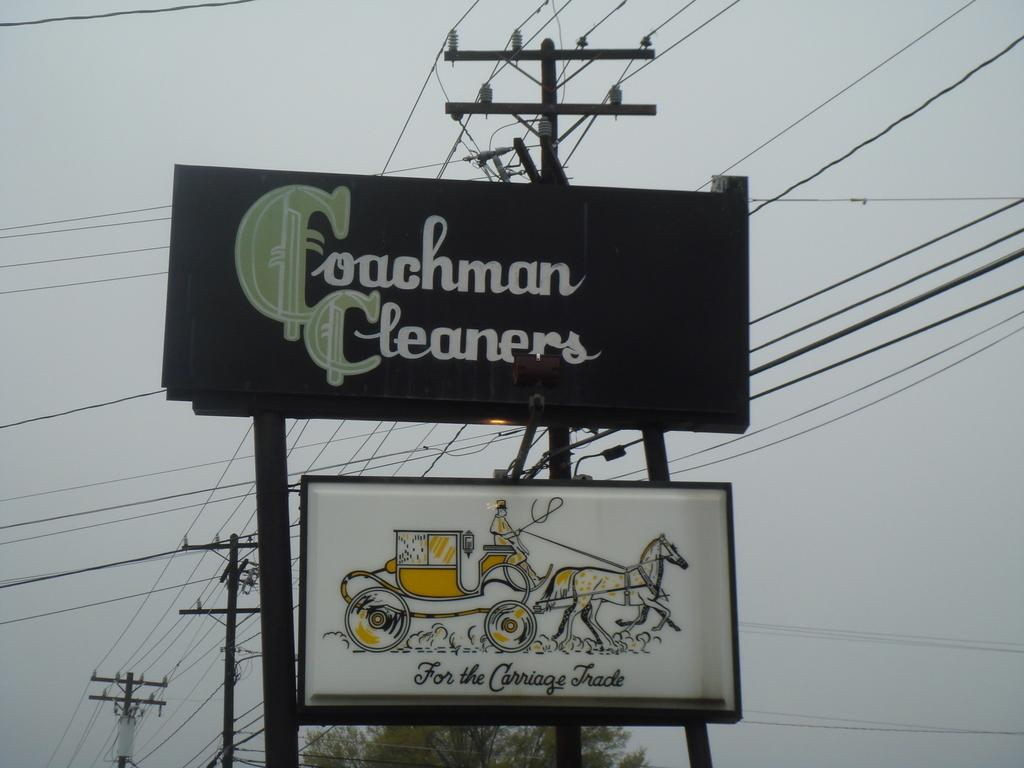<image>
Give a short and clear explanation of the subsequent image. Coachman cleaners sign is prominently displayed above a sign with a horse and carriage 